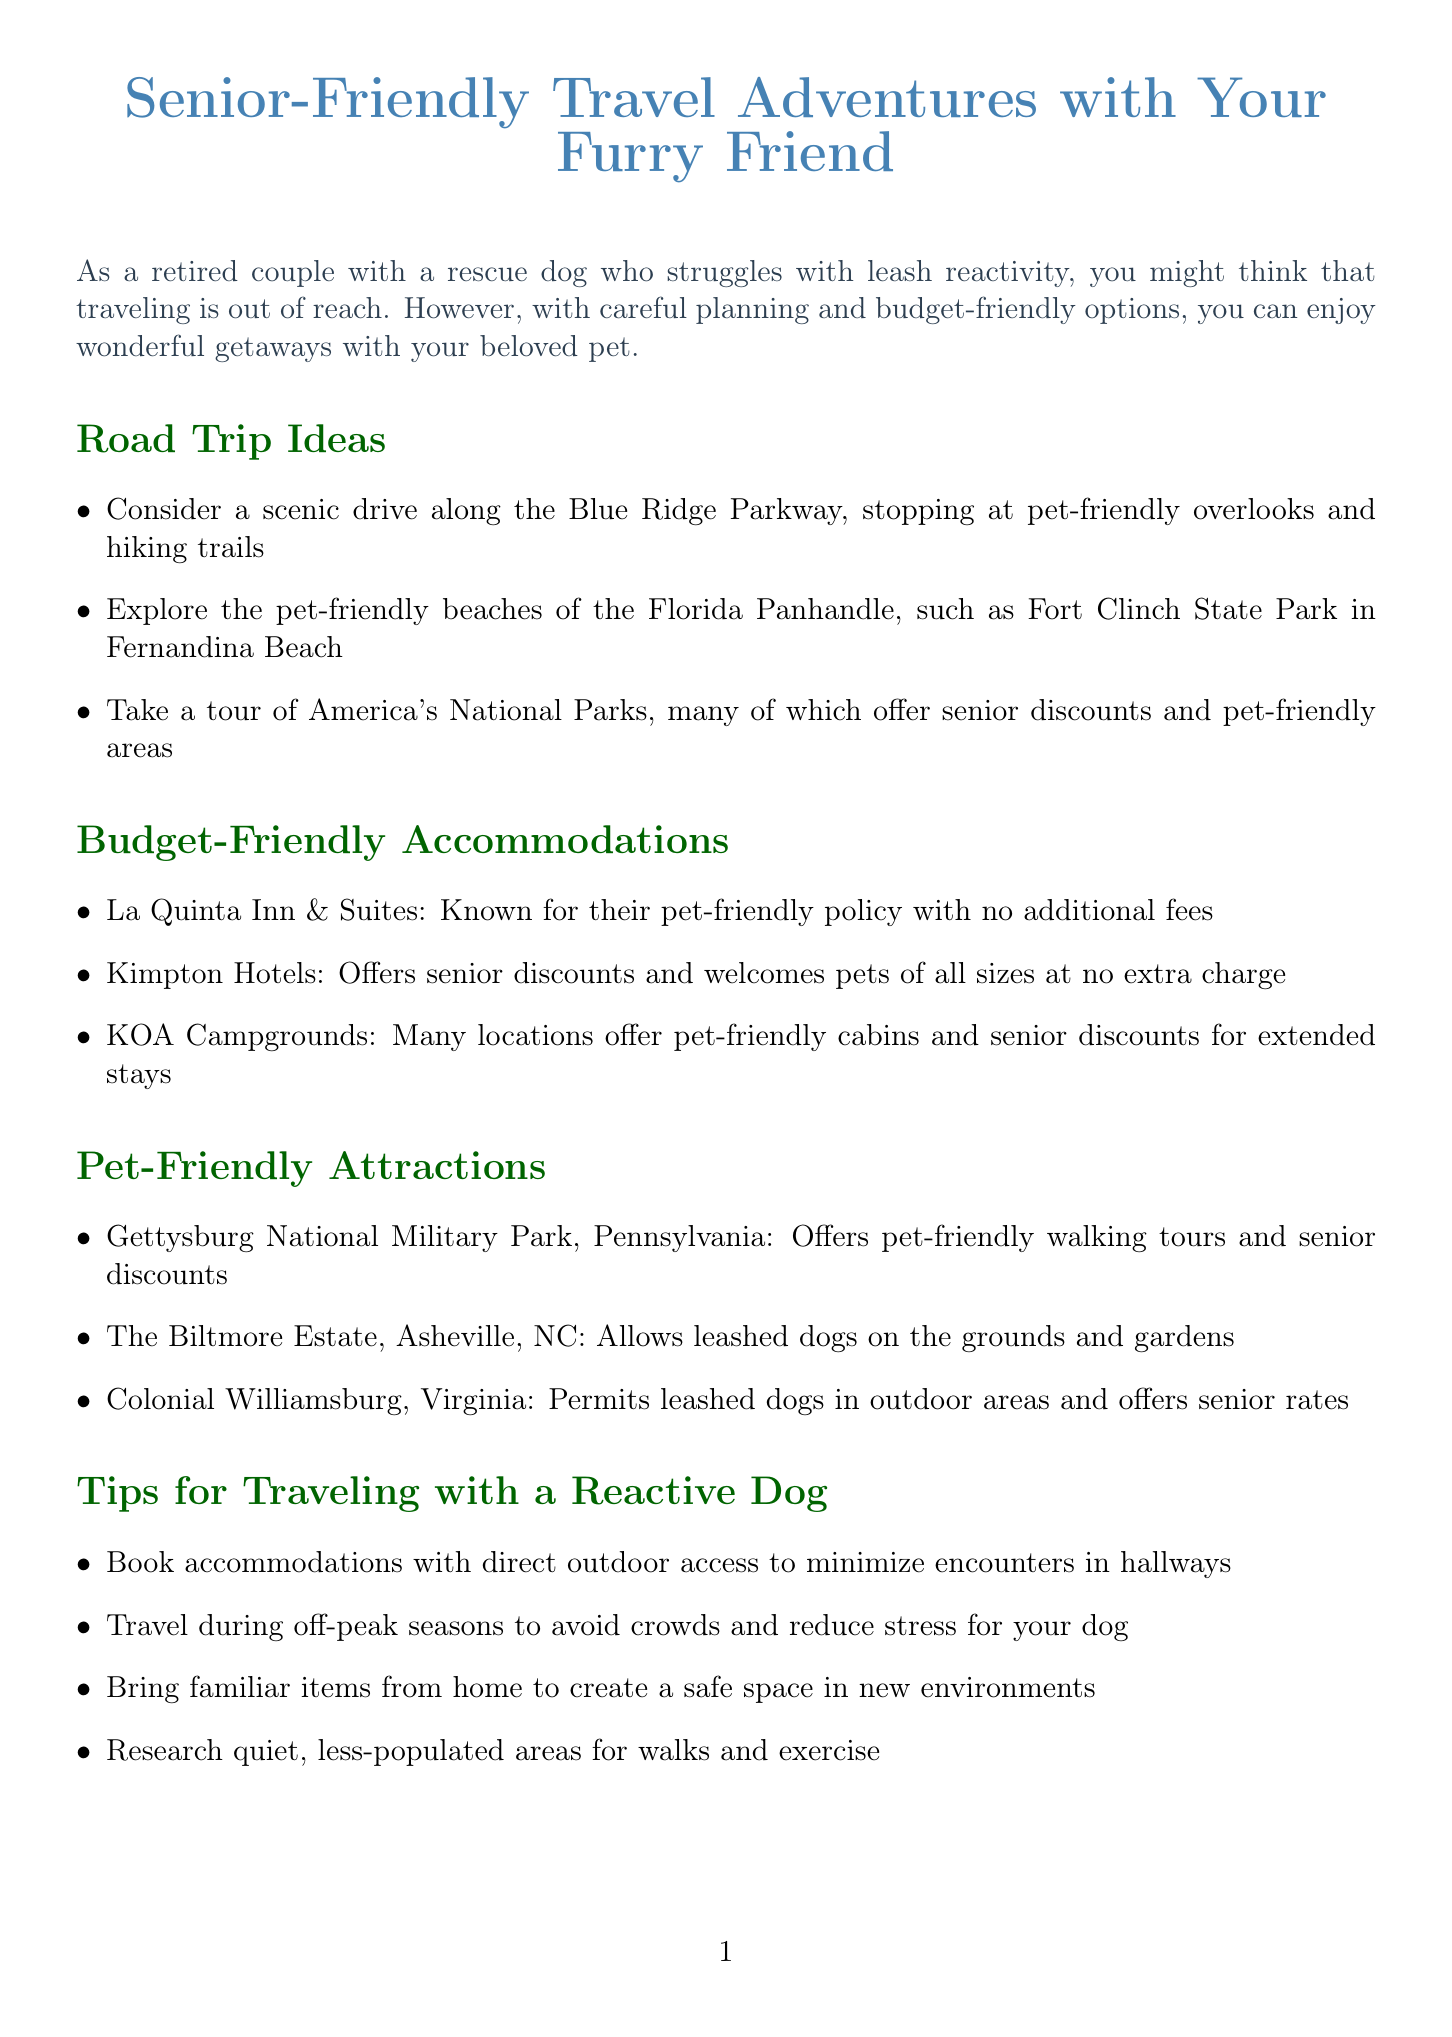What is the title of the newsletter? The title of the newsletter is presented at the beginning of the document, which is "Senior-Friendly Travel Adventures with Your Furry Friend."
Answer: Senior-Friendly Travel Adventures with Your Furry Friend What pet-friendly activities are suggested for Asheville, North Carolina? The document lists activities in Asheville, including visits to the Western North Carolina Nature Center and enjoying pet-friendly patios at restaurants.
Answer: Western North Carolina Nature Center What is one tip for traveling with a reactive dog? The document provides several tips, including booking accommodations with direct outdoor access to minimize encounters.
Answer: Direct outdoor access Which hotel chain has no additional fees for pets? The document specifically mentions La Quinta Inn & Suites as having a pet-friendly policy with no additional fees.
Answer: La Quinta Inn & Suites How much discount does Amtrak offer for travelers aged 65 and older? The newsletter mentions that Amtrak offers a 10% discount for this age group.
Answer: 10% What is a suggested road trip location? The document suggests several locations for road trips, including the Blue Ridge Parkway.
Answer: Blue Ridge Parkway What type of accommodations does KOA offer? According to the document, KOA Campgrounds offer pet-friendly cabins and senior discounts for extended stays.
Answer: Pet-friendly cabins Which attraction allows leashed dogs on the grounds? The Biltmore Estate in Asheville, NC, allows leashed dogs, as stated in the newsletter.
Answer: Biltmore Estate 